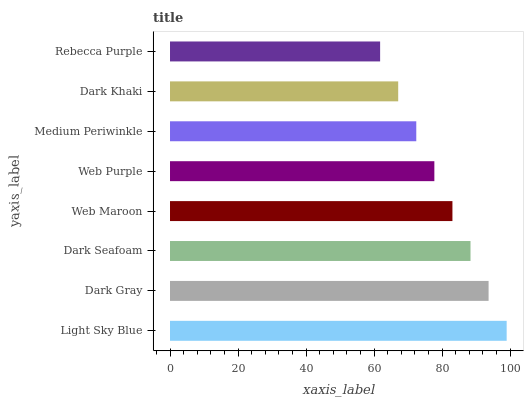Is Rebecca Purple the minimum?
Answer yes or no. Yes. Is Light Sky Blue the maximum?
Answer yes or no. Yes. Is Dark Gray the minimum?
Answer yes or no. No. Is Dark Gray the maximum?
Answer yes or no. No. Is Light Sky Blue greater than Dark Gray?
Answer yes or no. Yes. Is Dark Gray less than Light Sky Blue?
Answer yes or no. Yes. Is Dark Gray greater than Light Sky Blue?
Answer yes or no. No. Is Light Sky Blue less than Dark Gray?
Answer yes or no. No. Is Web Maroon the high median?
Answer yes or no. Yes. Is Web Purple the low median?
Answer yes or no. Yes. Is Light Sky Blue the high median?
Answer yes or no. No. Is Dark Khaki the low median?
Answer yes or no. No. 